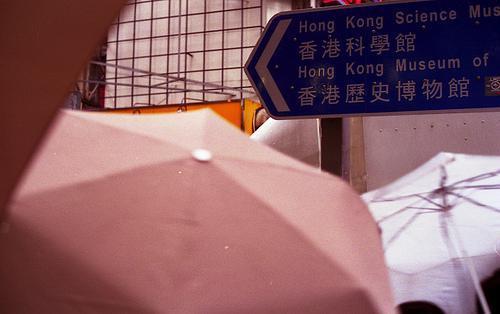How many umbrellas?
Give a very brief answer. 2. 